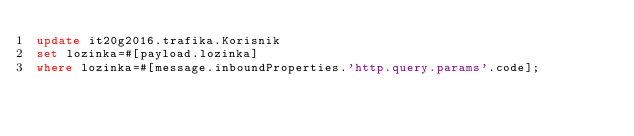Convert code to text. <code><loc_0><loc_0><loc_500><loc_500><_SQL_>update it20g2016.trafika.Korisnik
set lozinka=#[payload.lozinka]
where lozinka=#[message.inboundProperties.'http.query.params'.code];</code> 